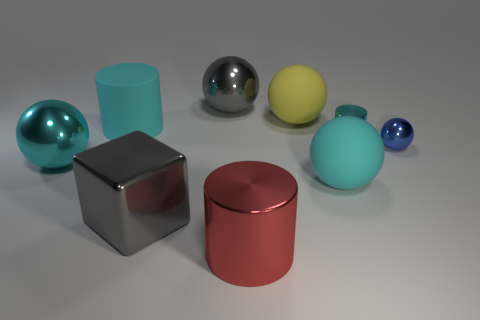Subtract all blue balls. How many balls are left? 4 Subtract all small blue metallic balls. How many balls are left? 4 Subtract all brown spheres. Subtract all blue cubes. How many spheres are left? 5 Add 1 small purple metallic things. How many objects exist? 10 Subtract all blocks. How many objects are left? 8 Subtract 0 purple cubes. How many objects are left? 9 Subtract all yellow cylinders. Subtract all small cyan cylinders. How many objects are left? 8 Add 8 large yellow rubber things. How many large yellow rubber things are left? 9 Add 4 large shiny cylinders. How many large shiny cylinders exist? 5 